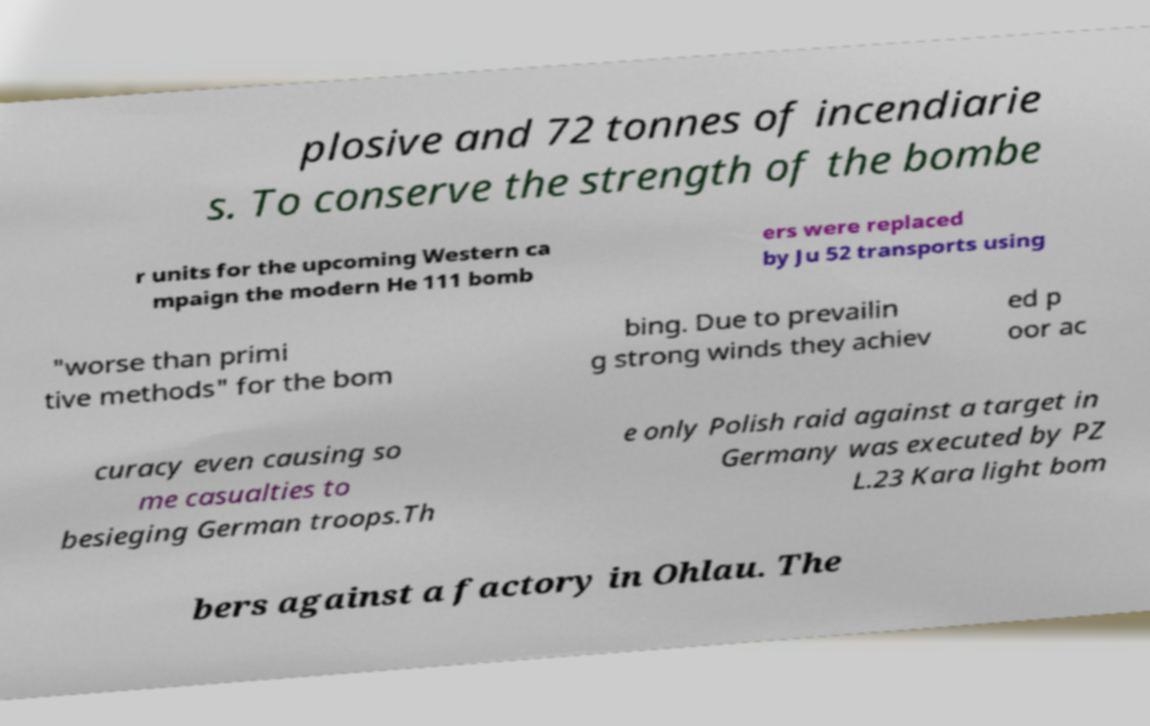There's text embedded in this image that I need extracted. Can you transcribe it verbatim? plosive and 72 tonnes of incendiarie s. To conserve the strength of the bombe r units for the upcoming Western ca mpaign the modern He 111 bomb ers were replaced by Ju 52 transports using "worse than primi tive methods" for the bom bing. Due to prevailin g strong winds they achiev ed p oor ac curacy even causing so me casualties to besieging German troops.Th e only Polish raid against a target in Germany was executed by PZ L.23 Kara light bom bers against a factory in Ohlau. The 